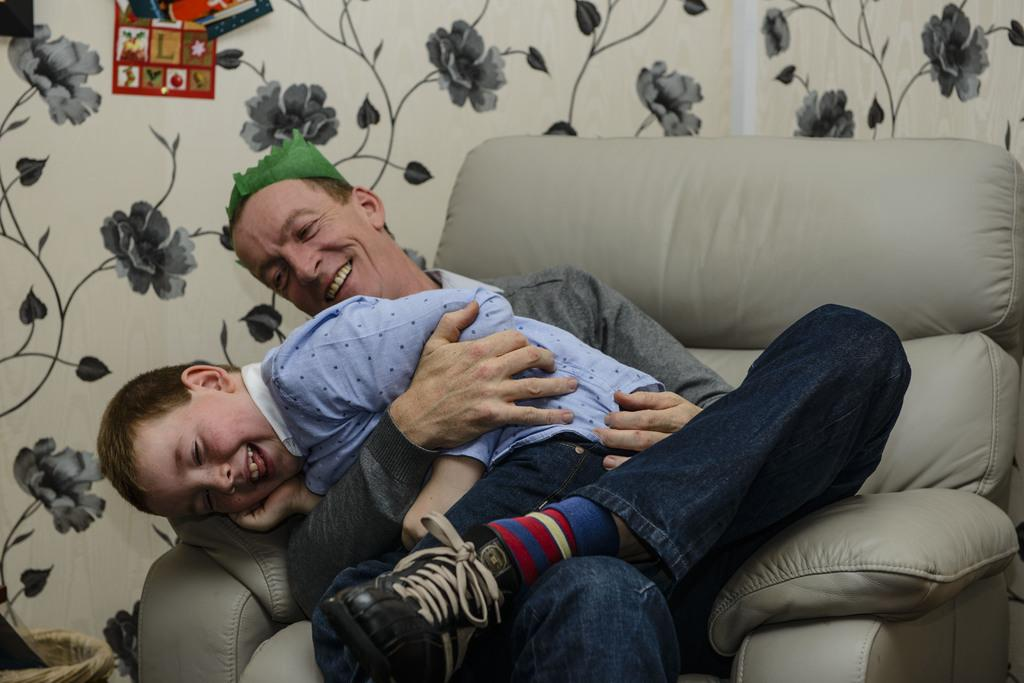Where is the setting of the image? The image is inside a room. Who are the people in the image? There are two people in the image: a man and a boy. What are the man and the boy doing in the image? The man and the boy are sitting on a couch. What can be seen in the background of the image? There are flowers visible in the background of the image. What type of scale is being used by the man and the boy in the image? There is no scale present in the image; it features a man and a boy sitting on a couch with flowers in the background. What scientific theory is being discussed by the man and the boy in the image? There is no indication in the image that the man and the boy are discussing any scientific theories. 